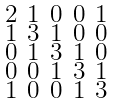Convert formula to latex. <formula><loc_0><loc_0><loc_500><loc_500>\begin{smallmatrix} 2 & 1 & 0 & 0 & 1 \\ 1 & 3 & 1 & 0 & 0 \\ 0 & 1 & 3 & 1 & 0 \\ 0 & 0 & 1 & 3 & 1 \\ 1 & 0 & 0 & 1 & 3 \end{smallmatrix}</formula> 